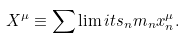<formula> <loc_0><loc_0><loc_500><loc_500>X ^ { \mu } \equiv \sum \lim i t s _ { n } m _ { n } x ^ { \mu } _ { n } .</formula> 